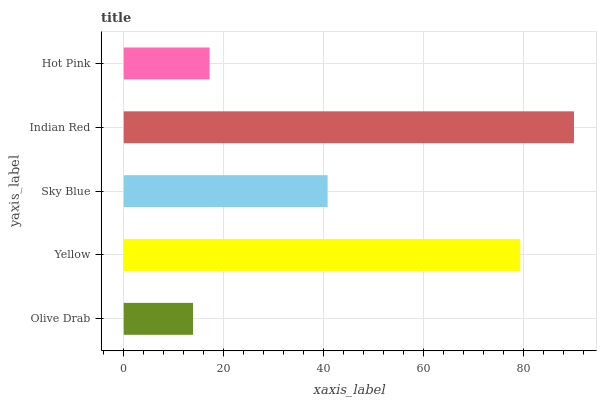Is Olive Drab the minimum?
Answer yes or no. Yes. Is Indian Red the maximum?
Answer yes or no. Yes. Is Yellow the minimum?
Answer yes or no. No. Is Yellow the maximum?
Answer yes or no. No. Is Yellow greater than Olive Drab?
Answer yes or no. Yes. Is Olive Drab less than Yellow?
Answer yes or no. Yes. Is Olive Drab greater than Yellow?
Answer yes or no. No. Is Yellow less than Olive Drab?
Answer yes or no. No. Is Sky Blue the high median?
Answer yes or no. Yes. Is Sky Blue the low median?
Answer yes or no. Yes. Is Olive Drab the high median?
Answer yes or no. No. Is Hot Pink the low median?
Answer yes or no. No. 